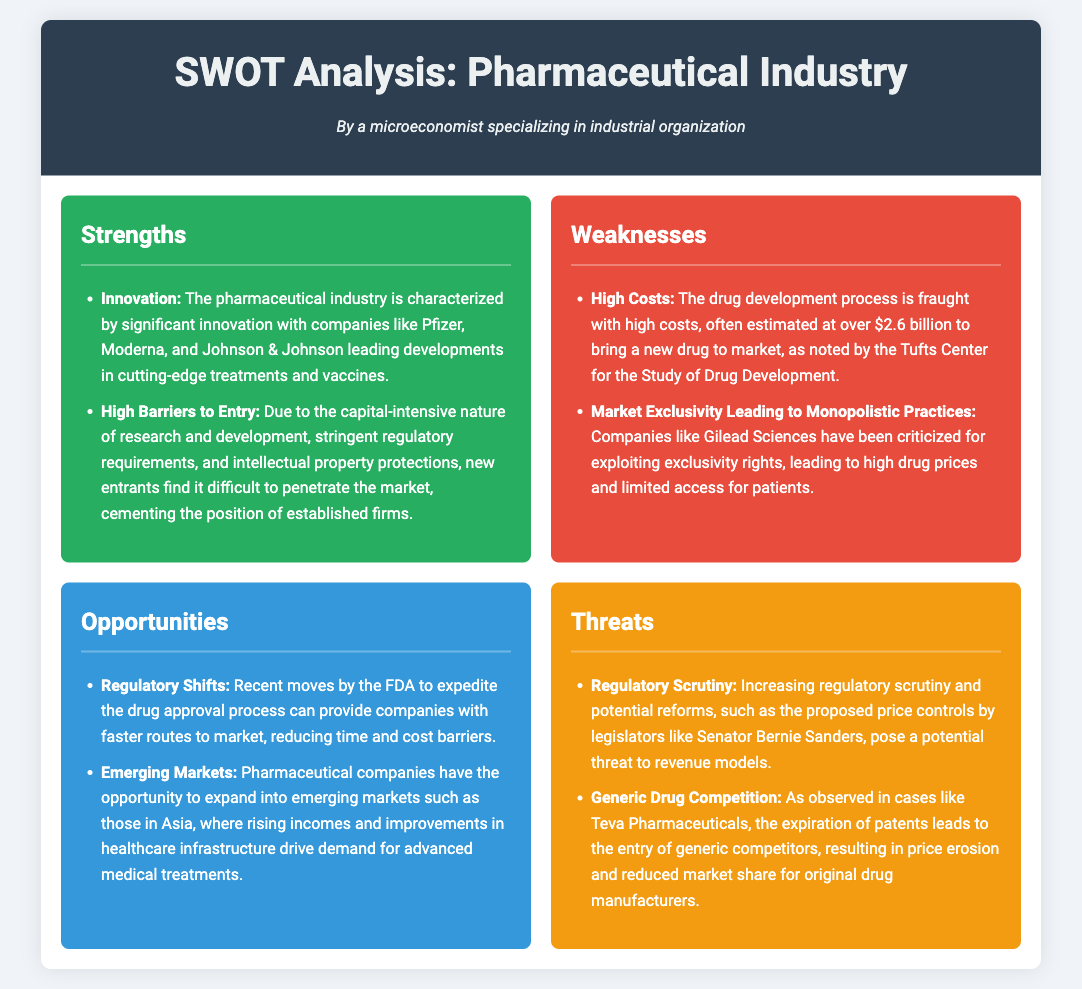What are two examples of strengths in the pharmaceutical industry? The document highlights innovation and high barriers to entry as key strengths of the pharmaceutical industry.
Answer: Innovation, high barriers to entry What is the estimated cost to bring a new drug to market? The document states that the drug development process often costs over $2.6 billion.
Answer: Over $2.6 billion Who are two companies mentioned for leading innovative developments? The document specifically mentions Pfizer and Moderna as companies leading in cutting-edge treatments and vaccines.
Answer: Pfizer, Moderna What regulatory changes can provide opportunities for pharmaceutical companies? The document notes that recent moves by the FDA to expedite the drug approval process represent an opportunity for companies.
Answer: FDA expedited drug approval process What is a threat posed by generic drug competition? The document indicates that the expiration of patents allows generic competitors to enter the market, leading to price erosion.
Answer: Price erosion What is a weakness related to market exclusivity? The document describes that companies exploit exclusivity rights, leading to high drug prices and limited access for patients as a weakness.
Answer: High drug prices, limited access Which emerging markets represent an opportunity for expansion? The document highlights that Asian markets represent opportunities for pharmaceutical expansion due to rising incomes and healthcare improvements.
Answer: Asian markets What is a specific threat from regulatory scrutiny? The document cites proposed price controls by legislators, such as Senator Bernie Sanders, as a potential threat to revenue models.
Answer: Proposed price controls 